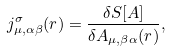Convert formula to latex. <formula><loc_0><loc_0><loc_500><loc_500>j ^ { \sigma } _ { \mu , \alpha \beta } ( { r } ) = \frac { \delta S [ { A } ] } { \delta A _ { \mu , \beta \alpha } ( { r } ) } ,</formula> 